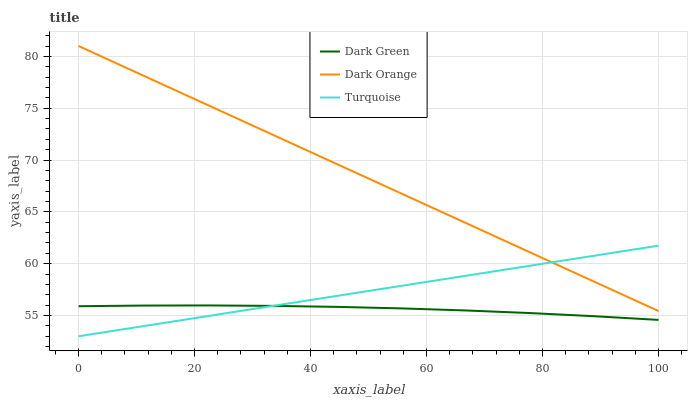Does Dark Green have the minimum area under the curve?
Answer yes or no. Yes. Does Dark Orange have the maximum area under the curve?
Answer yes or no. Yes. Does Turquoise have the minimum area under the curve?
Answer yes or no. No. Does Turquoise have the maximum area under the curve?
Answer yes or no. No. Is Turquoise the smoothest?
Answer yes or no. Yes. Is Dark Green the roughest?
Answer yes or no. Yes. Is Dark Green the smoothest?
Answer yes or no. No. Is Turquoise the roughest?
Answer yes or no. No. Does Dark Green have the lowest value?
Answer yes or no. No. Does Dark Orange have the highest value?
Answer yes or no. Yes. Does Turquoise have the highest value?
Answer yes or no. No. Is Dark Green less than Dark Orange?
Answer yes or no. Yes. Is Dark Orange greater than Dark Green?
Answer yes or no. Yes. Does Dark Orange intersect Turquoise?
Answer yes or no. Yes. Is Dark Orange less than Turquoise?
Answer yes or no. No. Is Dark Orange greater than Turquoise?
Answer yes or no. No. Does Dark Green intersect Dark Orange?
Answer yes or no. No. 